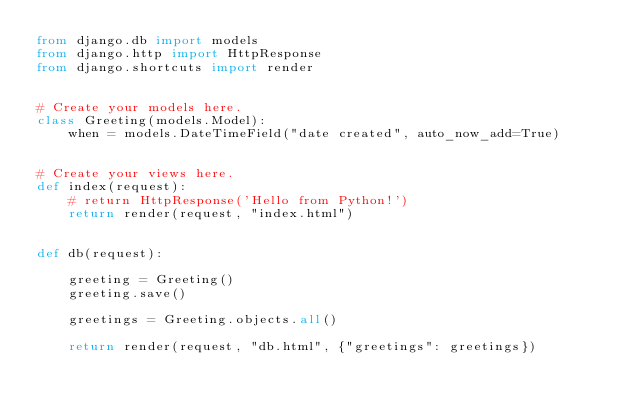<code> <loc_0><loc_0><loc_500><loc_500><_Python_>from django.db import models
from django.http import HttpResponse
from django.shortcuts import render


# Create your models here.
class Greeting(models.Model):
    when = models.DateTimeField("date created", auto_now_add=True)


# Create your views here.
def index(request):
    # return HttpResponse('Hello from Python!')
    return render(request, "index.html")


def db(request):

    greeting = Greeting()
    greeting.save()

    greetings = Greeting.objects.all()

    return render(request, "db.html", {"greetings": greetings})
</code> 